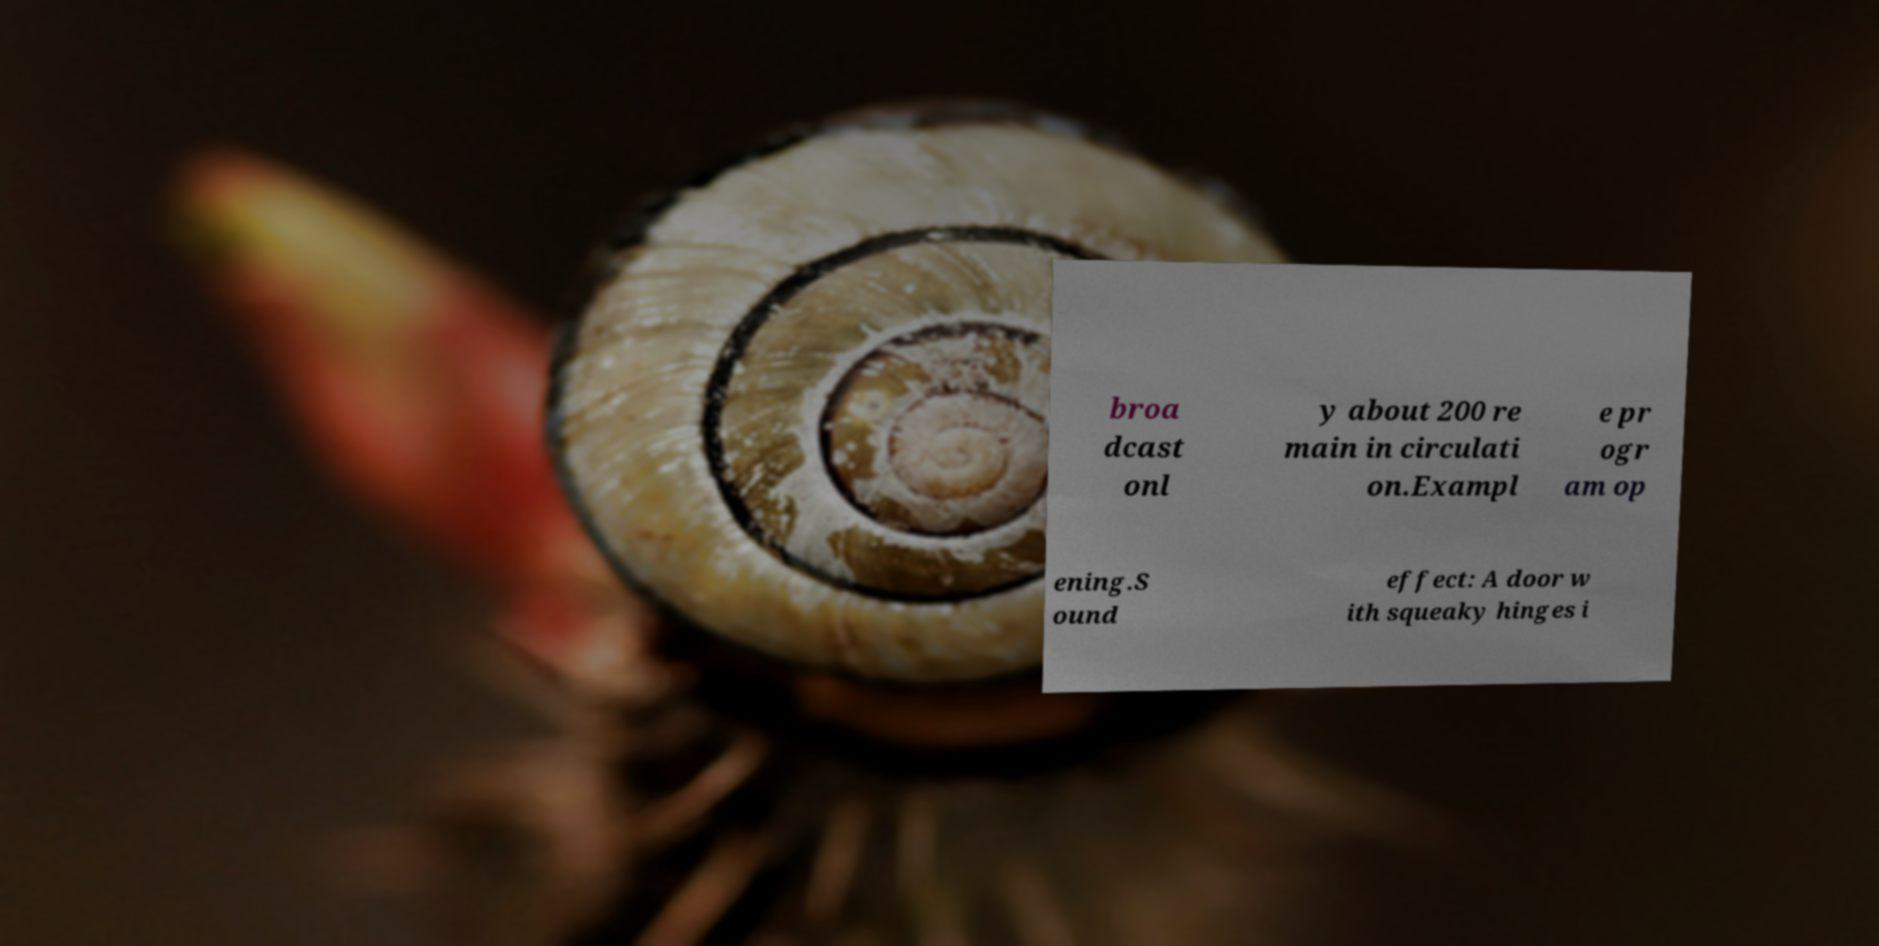For documentation purposes, I need the text within this image transcribed. Could you provide that? broa dcast onl y about 200 re main in circulati on.Exampl e pr ogr am op ening.S ound effect: A door w ith squeaky hinges i 